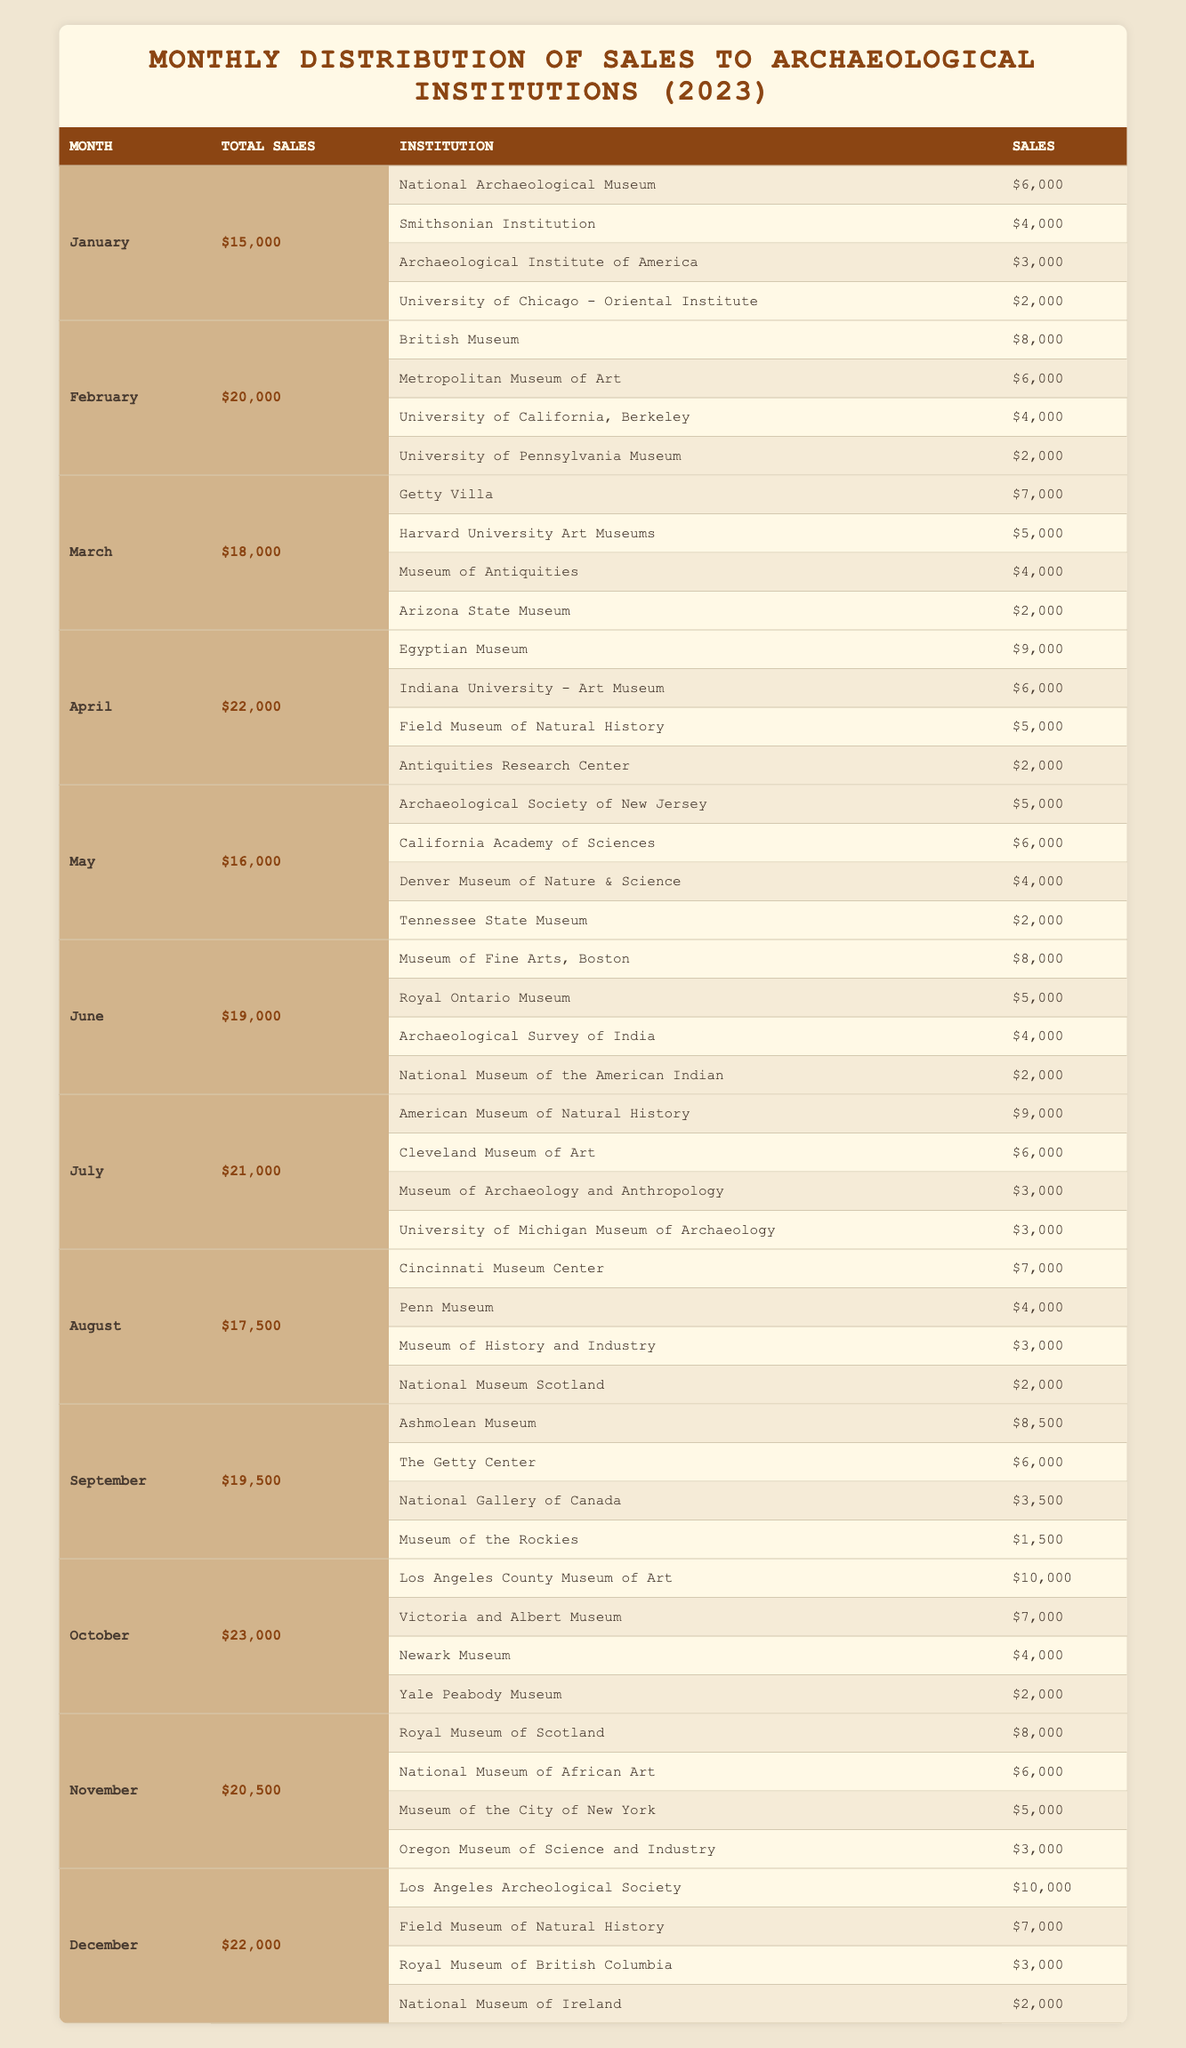What was the total sales for April? The table shows a row for April with the total sales indicated. By directly referring to the April section in the table, we can see that the total sales for April is $22,000.
Answer: $22,000 Which institution received the highest sales in June? Looking at the sales by institution for June, the highest value is found by comparing the sales amounts for each institution listed, with the Museum of Fine Arts, Boston receiving $8,000, which is the highest.
Answer: Museum of Fine Arts, Boston What is the average total sales for the first three months (January to March)? To calculate the average total sales for January ($15,000), February ($20,000), and March ($18,000), we first add these amounts: $15,000 + $20,000 + $18,000 = $53,000. Then, we divide this sum by 3, which gives us an average of $53,000 / 3 = $17,666.67.
Answer: $17,666.67 Did the National Museum of Ireland receive more than $2,000 in sales? Referring to December's sales, the National Museum of Ireland received $2,000 in sales, which is equal and not greater than $2,000, therefore the answer is no.
Answer: No Which month had the second-highest total sales? By evaluating the total sales for each month, we can see October had the highest sales at $23,000, and April comes next with $22,000. Therefore, April is the second-highest month.
Answer: April What was the difference in total sales between September and November? The total sales for September is $19,500 and for November is $20,500. To find the difference, we subtract September's total from November's total: $20,500 - $19,500 = $1,000.
Answer: $1,000 How many institutions received sales of $5,000 or more in July? In the July sales data, we need to count how many institutions have sales amounts equal to or greater than $5,000. The institutions listed are: American Museum of Natural History ($9,000), Cleveland Museum of Art ($6,000), and both the Museum of Archaeology and Anthropology and University of Michigan Museum of Archaeology received $3,000 each, hence only the first two meet the criteria. Thus, there are 2 institutions.
Answer: 2 Was there a month with total sales exceeding $24,000? Analyzing each month's total sales reveals that the highest monthly sales is $23,000 in October, meaning that none of the months have exceeded $24,000.
Answer: No 